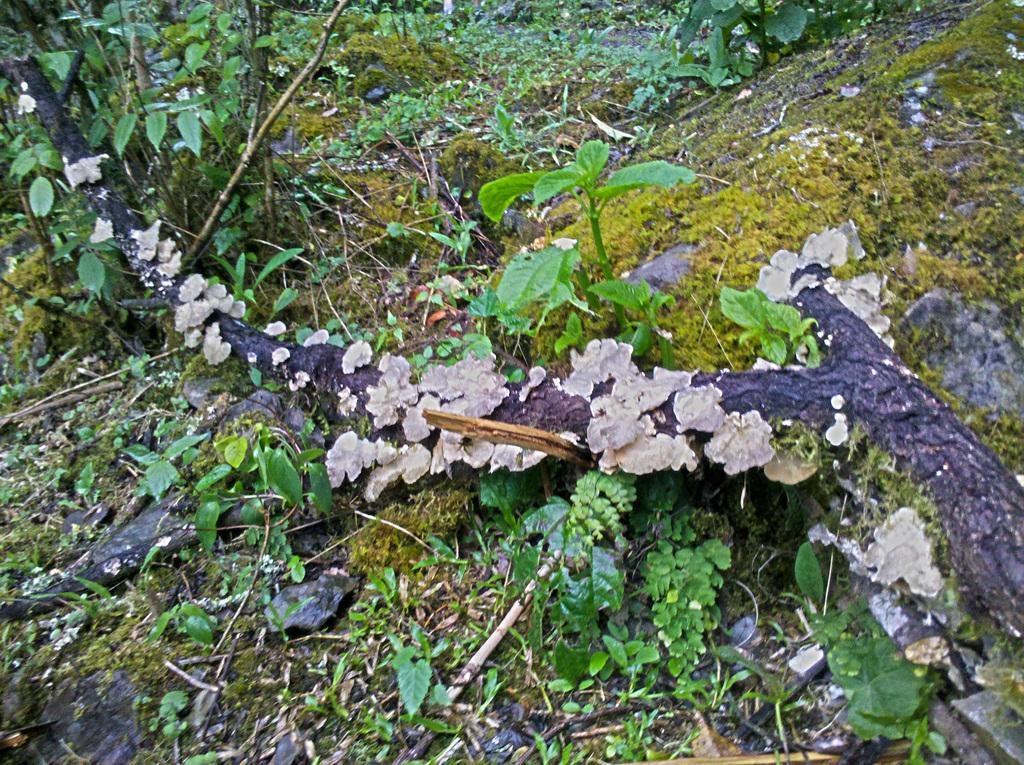Can you describe this image briefly? In this image there is a trunk of the tree fallen on the ground, there are plants, grass and some leaves on the ground. 